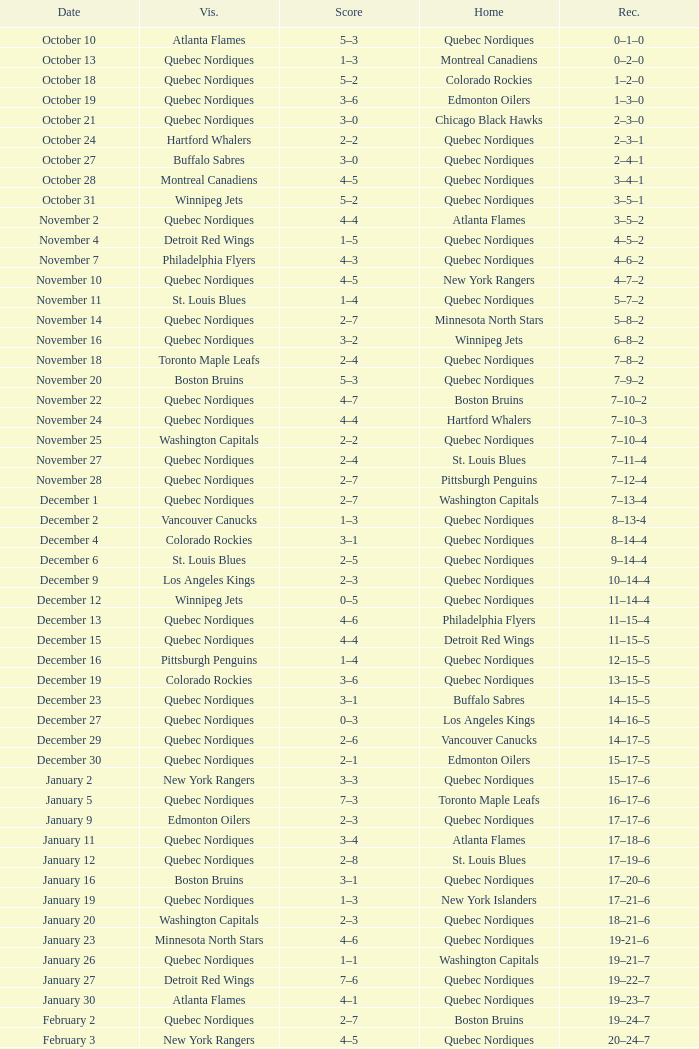Which Record has a Home of edmonton oilers, and a Score of 3–6? 1–3–0. 